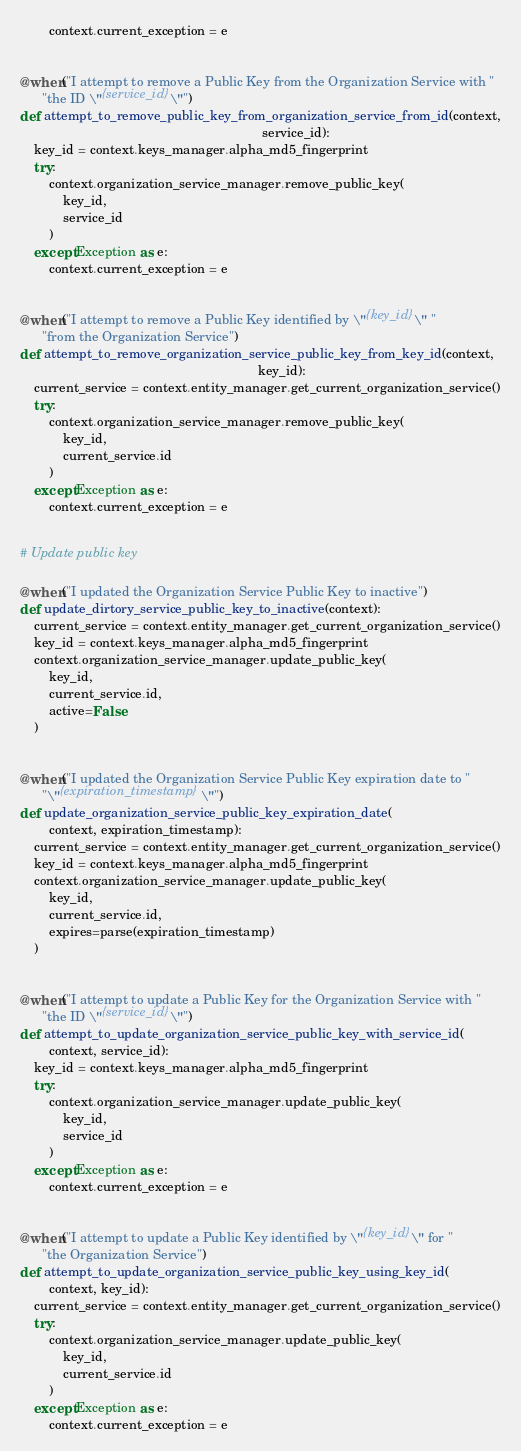<code> <loc_0><loc_0><loc_500><loc_500><_Python_>        context.current_exception = e


@when("I attempt to remove a Public Key from the Organization Service with "
      "the ID \"{service_id}\"")
def attempt_to_remove_public_key_from_organization_service_from_id(context,
                                                                   service_id):
    key_id = context.keys_manager.alpha_md5_fingerprint
    try:
        context.organization_service_manager.remove_public_key(
            key_id,
            service_id
        )
    except Exception as e:
        context.current_exception = e


@when("I attempt to remove a Public Key identified by \"{key_id}\" "
      "from the Organization Service")
def attempt_to_remove_organization_service_public_key_from_key_id(context,
                                                                  key_id):
    current_service = context.entity_manager.get_current_organization_service()
    try:
        context.organization_service_manager.remove_public_key(
            key_id,
            current_service.id
        )
    except Exception as e:
        context.current_exception = e


# Update public key

@when("I updated the Organization Service Public Key to inactive")
def update_dirtory_service_public_key_to_inactive(context):
    current_service = context.entity_manager.get_current_organization_service()
    key_id = context.keys_manager.alpha_md5_fingerprint
    context.organization_service_manager.update_public_key(
        key_id,
        current_service.id,
        active=False
    )


@when("I updated the Organization Service Public Key expiration date to "
      "\"{expiration_timestamp}\"")
def update_organization_service_public_key_expiration_date(
        context, expiration_timestamp):
    current_service = context.entity_manager.get_current_organization_service()
    key_id = context.keys_manager.alpha_md5_fingerprint
    context.organization_service_manager.update_public_key(
        key_id,
        current_service.id,
        expires=parse(expiration_timestamp)
    )


@when("I attempt to update a Public Key for the Organization Service with "
      "the ID \"{service_id}\"")
def attempt_to_update_organization_service_public_key_with_service_id(
        context, service_id):
    key_id = context.keys_manager.alpha_md5_fingerprint
    try:
        context.organization_service_manager.update_public_key(
            key_id,
            service_id
        )
    except Exception as e:
        context.current_exception = e


@when("I attempt to update a Public Key identified by \"{key_id}\" for "
      "the Organization Service")
def attempt_to_update_organization_service_public_key_using_key_id(
        context, key_id):
    current_service = context.entity_manager.get_current_organization_service()
    try:
        context.organization_service_manager.update_public_key(
            key_id,
            current_service.id
        )
    except Exception as e:
        context.current_exception = e
</code> 